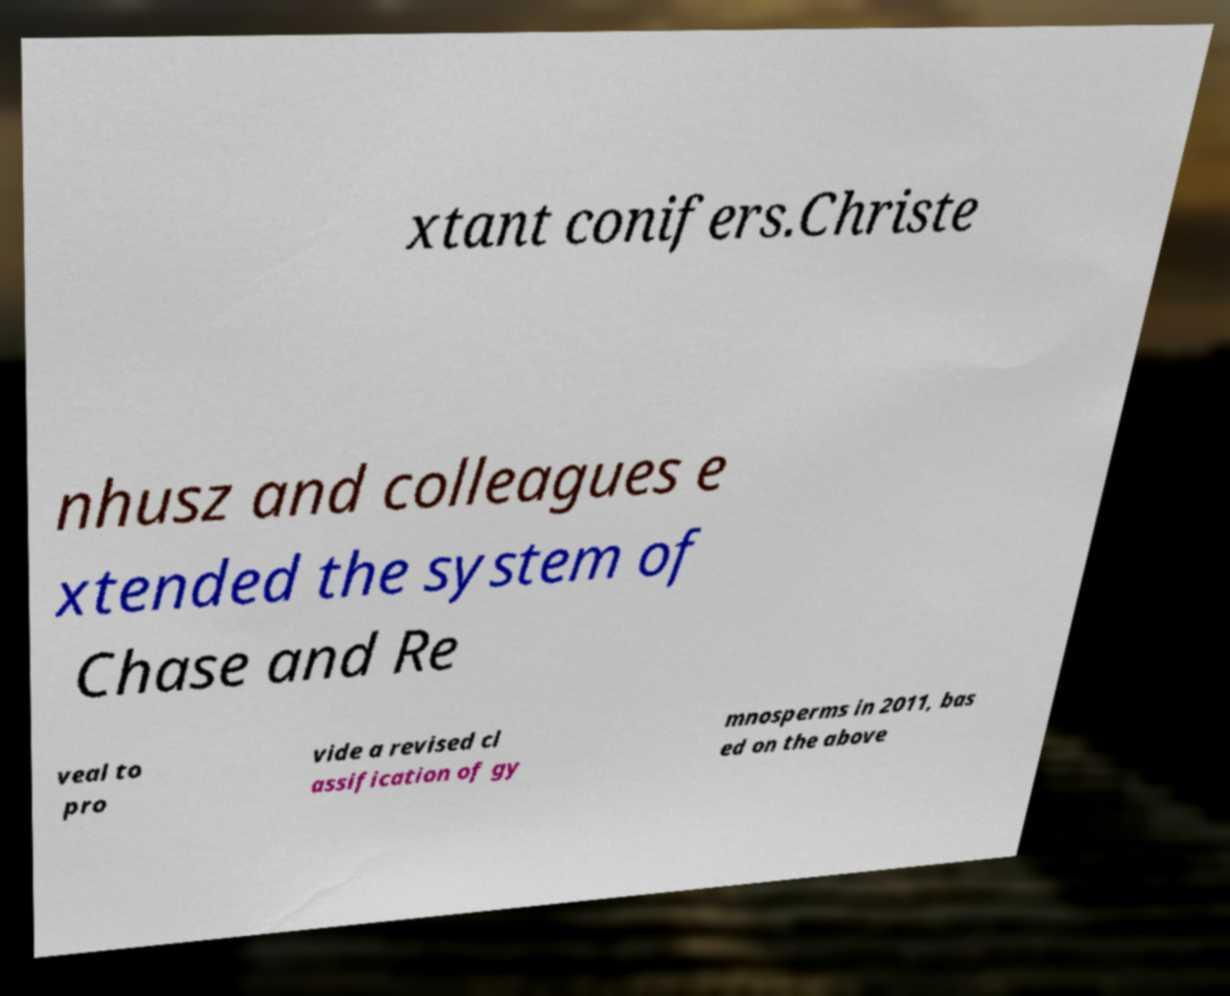Can you accurately transcribe the text from the provided image for me? xtant conifers.Christe nhusz and colleagues e xtended the system of Chase and Re veal to pro vide a revised cl assification of gy mnosperms in 2011, bas ed on the above 